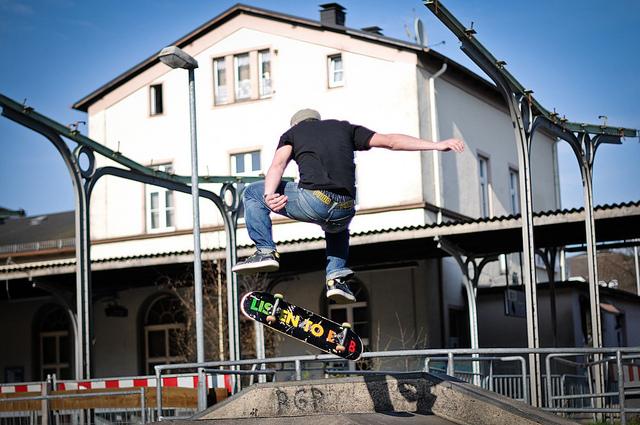What kind of pants is the man wearing?
Answer briefly. Jeans. What color is the building?
Keep it brief. White. What does the skateboard say?
Be succinct. Listen to bob. 